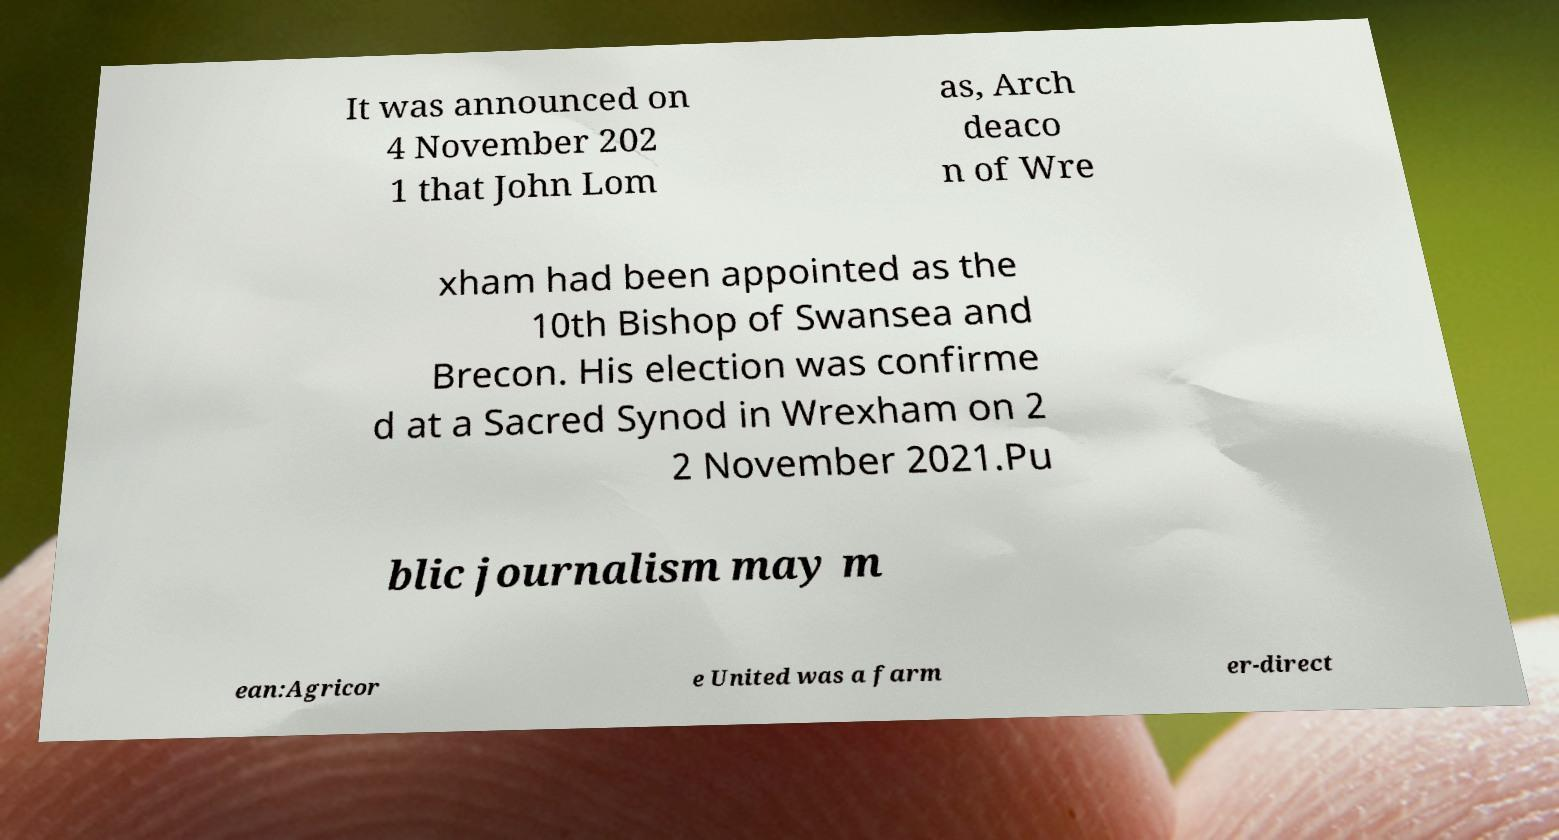Can you read and provide the text displayed in the image?This photo seems to have some interesting text. Can you extract and type it out for me? It was announced on 4 November 202 1 that John Lom as, Arch deaco n of Wre xham had been appointed as the 10th Bishop of Swansea and Brecon. His election was confirme d at a Sacred Synod in Wrexham on 2 2 November 2021.Pu blic journalism may m ean:Agricor e United was a farm er-direct 